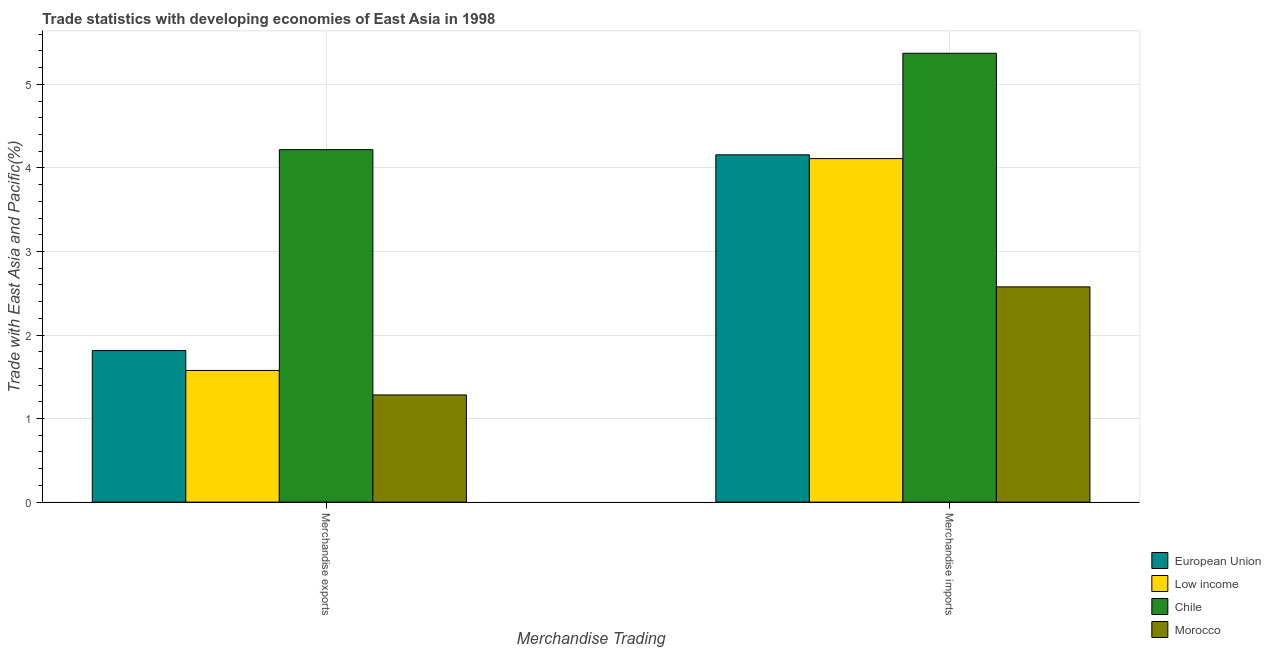How many groups of bars are there?
Offer a terse response. 2. Are the number of bars per tick equal to the number of legend labels?
Ensure brevity in your answer.  Yes. Are the number of bars on each tick of the X-axis equal?
Provide a succinct answer. Yes. How many bars are there on the 1st tick from the left?
Keep it short and to the point. 4. What is the merchandise exports in Chile?
Ensure brevity in your answer.  4.22. Across all countries, what is the maximum merchandise exports?
Offer a very short reply. 4.22. Across all countries, what is the minimum merchandise imports?
Make the answer very short. 2.58. In which country was the merchandise imports minimum?
Keep it short and to the point. Morocco. What is the total merchandise exports in the graph?
Provide a short and direct response. 8.89. What is the difference between the merchandise exports in European Union and that in Low income?
Offer a very short reply. 0.24. What is the difference between the merchandise imports in European Union and the merchandise exports in Morocco?
Keep it short and to the point. 2.87. What is the average merchandise exports per country?
Your answer should be compact. 2.22. What is the difference between the merchandise exports and merchandise imports in Morocco?
Ensure brevity in your answer.  -1.29. In how many countries, is the merchandise exports greater than 4 %?
Ensure brevity in your answer.  1. What is the ratio of the merchandise imports in Morocco to that in European Union?
Provide a short and direct response. 0.62. Is the merchandise exports in Morocco less than that in European Union?
Provide a short and direct response. Yes. In how many countries, is the merchandise exports greater than the average merchandise exports taken over all countries?
Your answer should be very brief. 1. What does the 4th bar from the left in Merchandise exports represents?
Your response must be concise. Morocco. What is the difference between two consecutive major ticks on the Y-axis?
Your answer should be very brief. 1. Are the values on the major ticks of Y-axis written in scientific E-notation?
Ensure brevity in your answer.  No. Does the graph contain grids?
Provide a short and direct response. Yes. What is the title of the graph?
Make the answer very short. Trade statistics with developing economies of East Asia in 1998. What is the label or title of the X-axis?
Your response must be concise. Merchandise Trading. What is the label or title of the Y-axis?
Offer a very short reply. Trade with East Asia and Pacific(%). What is the Trade with East Asia and Pacific(%) of European Union in Merchandise exports?
Keep it short and to the point. 1.81. What is the Trade with East Asia and Pacific(%) of Low income in Merchandise exports?
Offer a very short reply. 1.58. What is the Trade with East Asia and Pacific(%) of Chile in Merchandise exports?
Offer a terse response. 4.22. What is the Trade with East Asia and Pacific(%) of Morocco in Merchandise exports?
Your answer should be very brief. 1.28. What is the Trade with East Asia and Pacific(%) in European Union in Merchandise imports?
Your answer should be compact. 4.16. What is the Trade with East Asia and Pacific(%) in Low income in Merchandise imports?
Make the answer very short. 4.11. What is the Trade with East Asia and Pacific(%) in Chile in Merchandise imports?
Give a very brief answer. 5.37. What is the Trade with East Asia and Pacific(%) in Morocco in Merchandise imports?
Keep it short and to the point. 2.58. Across all Merchandise Trading, what is the maximum Trade with East Asia and Pacific(%) of European Union?
Give a very brief answer. 4.16. Across all Merchandise Trading, what is the maximum Trade with East Asia and Pacific(%) in Low income?
Make the answer very short. 4.11. Across all Merchandise Trading, what is the maximum Trade with East Asia and Pacific(%) in Chile?
Keep it short and to the point. 5.37. Across all Merchandise Trading, what is the maximum Trade with East Asia and Pacific(%) in Morocco?
Ensure brevity in your answer.  2.58. Across all Merchandise Trading, what is the minimum Trade with East Asia and Pacific(%) in European Union?
Keep it short and to the point. 1.81. Across all Merchandise Trading, what is the minimum Trade with East Asia and Pacific(%) of Low income?
Keep it short and to the point. 1.58. Across all Merchandise Trading, what is the minimum Trade with East Asia and Pacific(%) of Chile?
Make the answer very short. 4.22. Across all Merchandise Trading, what is the minimum Trade with East Asia and Pacific(%) in Morocco?
Your answer should be compact. 1.28. What is the total Trade with East Asia and Pacific(%) in European Union in the graph?
Your response must be concise. 5.97. What is the total Trade with East Asia and Pacific(%) of Low income in the graph?
Provide a short and direct response. 5.69. What is the total Trade with East Asia and Pacific(%) in Chile in the graph?
Make the answer very short. 9.59. What is the total Trade with East Asia and Pacific(%) in Morocco in the graph?
Provide a succinct answer. 3.86. What is the difference between the Trade with East Asia and Pacific(%) of European Union in Merchandise exports and that in Merchandise imports?
Keep it short and to the point. -2.34. What is the difference between the Trade with East Asia and Pacific(%) of Low income in Merchandise exports and that in Merchandise imports?
Your answer should be very brief. -2.54. What is the difference between the Trade with East Asia and Pacific(%) of Chile in Merchandise exports and that in Merchandise imports?
Your answer should be very brief. -1.15. What is the difference between the Trade with East Asia and Pacific(%) in Morocco in Merchandise exports and that in Merchandise imports?
Offer a terse response. -1.29. What is the difference between the Trade with East Asia and Pacific(%) of European Union in Merchandise exports and the Trade with East Asia and Pacific(%) of Low income in Merchandise imports?
Your answer should be compact. -2.3. What is the difference between the Trade with East Asia and Pacific(%) of European Union in Merchandise exports and the Trade with East Asia and Pacific(%) of Chile in Merchandise imports?
Provide a short and direct response. -3.56. What is the difference between the Trade with East Asia and Pacific(%) of European Union in Merchandise exports and the Trade with East Asia and Pacific(%) of Morocco in Merchandise imports?
Offer a very short reply. -0.76. What is the difference between the Trade with East Asia and Pacific(%) of Low income in Merchandise exports and the Trade with East Asia and Pacific(%) of Chile in Merchandise imports?
Ensure brevity in your answer.  -3.8. What is the difference between the Trade with East Asia and Pacific(%) in Low income in Merchandise exports and the Trade with East Asia and Pacific(%) in Morocco in Merchandise imports?
Ensure brevity in your answer.  -1. What is the difference between the Trade with East Asia and Pacific(%) of Chile in Merchandise exports and the Trade with East Asia and Pacific(%) of Morocco in Merchandise imports?
Your response must be concise. 1.64. What is the average Trade with East Asia and Pacific(%) in European Union per Merchandise Trading?
Offer a terse response. 2.99. What is the average Trade with East Asia and Pacific(%) in Low income per Merchandise Trading?
Offer a terse response. 2.84. What is the average Trade with East Asia and Pacific(%) of Chile per Merchandise Trading?
Your response must be concise. 4.79. What is the average Trade with East Asia and Pacific(%) in Morocco per Merchandise Trading?
Provide a succinct answer. 1.93. What is the difference between the Trade with East Asia and Pacific(%) of European Union and Trade with East Asia and Pacific(%) of Low income in Merchandise exports?
Your answer should be compact. 0.24. What is the difference between the Trade with East Asia and Pacific(%) in European Union and Trade with East Asia and Pacific(%) in Chile in Merchandise exports?
Make the answer very short. -2.4. What is the difference between the Trade with East Asia and Pacific(%) in European Union and Trade with East Asia and Pacific(%) in Morocco in Merchandise exports?
Offer a very short reply. 0.53. What is the difference between the Trade with East Asia and Pacific(%) of Low income and Trade with East Asia and Pacific(%) of Chile in Merchandise exports?
Keep it short and to the point. -2.64. What is the difference between the Trade with East Asia and Pacific(%) of Low income and Trade with East Asia and Pacific(%) of Morocco in Merchandise exports?
Provide a succinct answer. 0.29. What is the difference between the Trade with East Asia and Pacific(%) in Chile and Trade with East Asia and Pacific(%) in Morocco in Merchandise exports?
Ensure brevity in your answer.  2.94. What is the difference between the Trade with East Asia and Pacific(%) of European Union and Trade with East Asia and Pacific(%) of Low income in Merchandise imports?
Make the answer very short. 0.05. What is the difference between the Trade with East Asia and Pacific(%) in European Union and Trade with East Asia and Pacific(%) in Chile in Merchandise imports?
Make the answer very short. -1.22. What is the difference between the Trade with East Asia and Pacific(%) in European Union and Trade with East Asia and Pacific(%) in Morocco in Merchandise imports?
Your answer should be very brief. 1.58. What is the difference between the Trade with East Asia and Pacific(%) of Low income and Trade with East Asia and Pacific(%) of Chile in Merchandise imports?
Keep it short and to the point. -1.26. What is the difference between the Trade with East Asia and Pacific(%) of Low income and Trade with East Asia and Pacific(%) of Morocco in Merchandise imports?
Keep it short and to the point. 1.53. What is the difference between the Trade with East Asia and Pacific(%) of Chile and Trade with East Asia and Pacific(%) of Morocco in Merchandise imports?
Give a very brief answer. 2.8. What is the ratio of the Trade with East Asia and Pacific(%) in European Union in Merchandise exports to that in Merchandise imports?
Provide a succinct answer. 0.44. What is the ratio of the Trade with East Asia and Pacific(%) in Low income in Merchandise exports to that in Merchandise imports?
Give a very brief answer. 0.38. What is the ratio of the Trade with East Asia and Pacific(%) of Chile in Merchandise exports to that in Merchandise imports?
Give a very brief answer. 0.79. What is the ratio of the Trade with East Asia and Pacific(%) of Morocco in Merchandise exports to that in Merchandise imports?
Provide a succinct answer. 0.5. What is the difference between the highest and the second highest Trade with East Asia and Pacific(%) in European Union?
Offer a very short reply. 2.34. What is the difference between the highest and the second highest Trade with East Asia and Pacific(%) of Low income?
Ensure brevity in your answer.  2.54. What is the difference between the highest and the second highest Trade with East Asia and Pacific(%) of Chile?
Give a very brief answer. 1.15. What is the difference between the highest and the second highest Trade with East Asia and Pacific(%) in Morocco?
Give a very brief answer. 1.29. What is the difference between the highest and the lowest Trade with East Asia and Pacific(%) of European Union?
Your answer should be very brief. 2.34. What is the difference between the highest and the lowest Trade with East Asia and Pacific(%) of Low income?
Provide a succinct answer. 2.54. What is the difference between the highest and the lowest Trade with East Asia and Pacific(%) in Chile?
Ensure brevity in your answer.  1.15. What is the difference between the highest and the lowest Trade with East Asia and Pacific(%) of Morocco?
Offer a terse response. 1.29. 